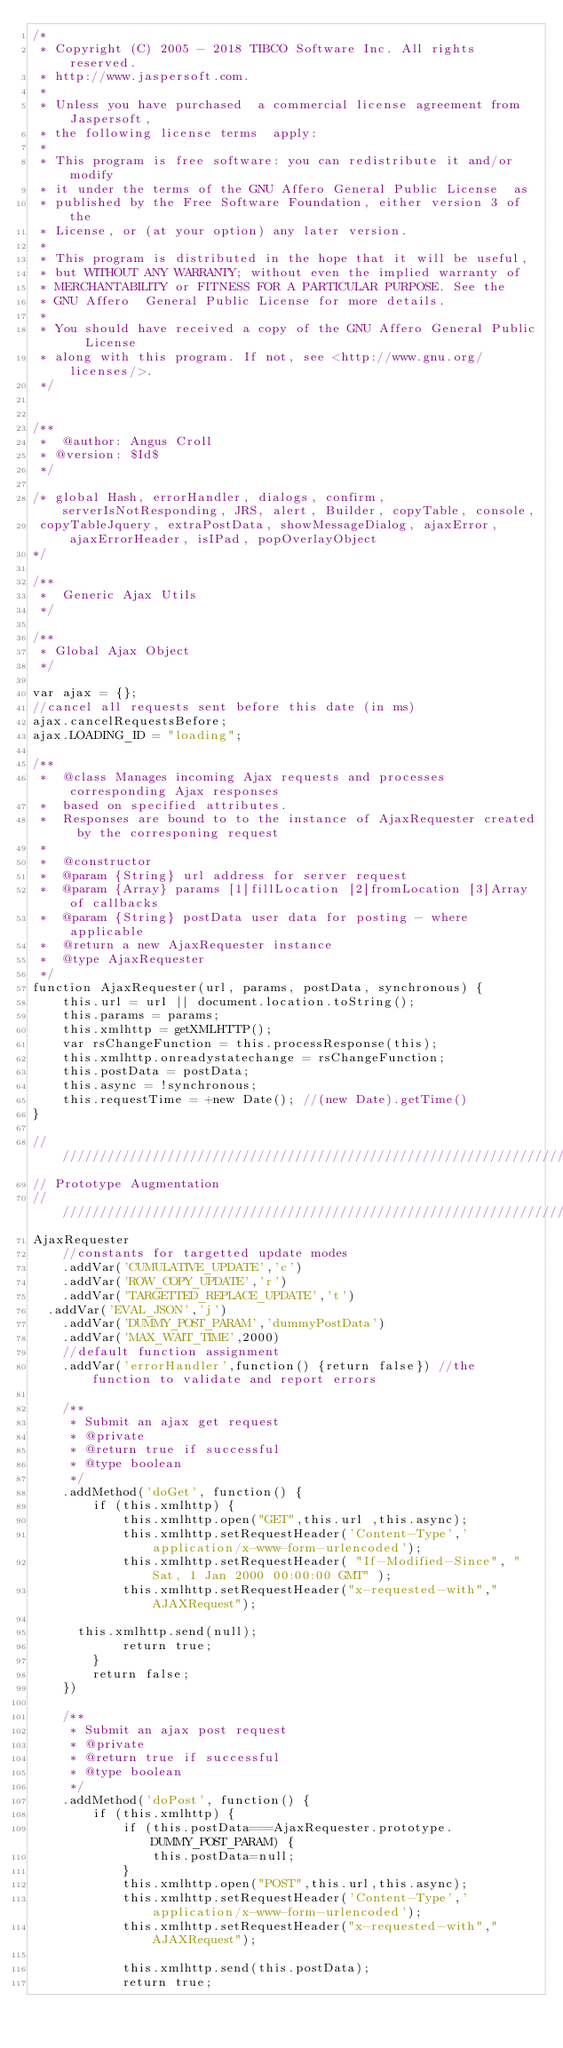Convert code to text. <code><loc_0><loc_0><loc_500><loc_500><_JavaScript_>/*
 * Copyright (C) 2005 - 2018 TIBCO Software Inc. All rights reserved.
 * http://www.jaspersoft.com.
 *
 * Unless you have purchased  a commercial license agreement from Jaspersoft,
 * the following license terms  apply:
 *
 * This program is free software: you can redistribute it and/or  modify
 * it under the terms of the GNU Affero General Public License  as
 * published by the Free Software Foundation, either version 3 of  the
 * License, or (at your option) any later version.
 *
 * This program is distributed in the hope that it will be useful,
 * but WITHOUT ANY WARRANTY; without even the implied warranty of
 * MERCHANTABILITY or FITNESS FOR A PARTICULAR PURPOSE. See the
 * GNU Affero  General Public License for more details.
 *
 * You should have received a copy of the GNU Affero General Public  License
 * along with this program. If not, see <http://www.gnu.org/licenses/>.
 */


/**
 *  @author: Angus Croll
 * @version: $Id$
 */

/* global Hash, errorHandler, dialogs, confirm, serverIsNotResponding, JRS, alert, Builder, copyTable, console,
 copyTableJquery, extraPostData, showMessageDialog, ajaxError, ajaxErrorHeader, isIPad, popOverlayObject
*/

/**
 *  Generic Ajax Utils
 */

/**
 * Global Ajax Object
 */

var ajax = {};
//cancel all requests sent before this date (in ms)
ajax.cancelRequestsBefore;
ajax.LOADING_ID = "loading";

/**
 *  @class Manages incoming Ajax requests and processes corresponding Ajax responses
 *  based on specified attributes.
 *  Responses are bound to to the instance of AjaxRequester created by the corresponing request
 *
 *  @constructor
 *  @param {String} url address for server request
 *  @param {Array} params [1]fillLocation [2]fromLocation [3]Array of callbacks
 *  @param {String} postData user data for posting - where applicable
 *  @return a new AjaxRequester instance
 *  @type AjaxRequester
 */
function AjaxRequester(url, params, postData, synchronous) {
    this.url = url || document.location.toString();
    this.params = params;
    this.xmlhttp = getXMLHTTP();
    var rsChangeFunction = this.processResponse(this);
    this.xmlhttp.onreadystatechange = rsChangeFunction;
    this.postData = postData;
    this.async = !synchronous;
    this.requestTime = +new Date(); //(new Date).getTime()
}

/////////////////////////////////////////////////////////////////////////
// Prototype Augmentation
/////////////////////////////////////////////////////////////////////////
AjaxRequester
    //constants for targetted update modes
    .addVar('CUMULATIVE_UPDATE','c')
    .addVar('ROW_COPY_UPDATE','r')
    .addVar('TARGETTED_REPLACE_UPDATE','t')
	.addVar('EVAL_JSON','j')
    .addVar('DUMMY_POST_PARAM','dummyPostData')
    .addVar('MAX_WAIT_TIME',2000)
    //default function assignment
    .addVar('errorHandler',function() {return false}) //the function to validate and report errors

    /**
     * Submit an ajax get request
     * @private
     * @return true if successful
     * @type boolean
     */
    .addMethod('doGet', function() {
        if (this.xmlhttp) {
            this.xmlhttp.open("GET",this.url ,this.async);
            this.xmlhttp.setRequestHeader('Content-Type','application/x-www-form-urlencoded');
            this.xmlhttp.setRequestHeader( "If-Modified-Since", "Sat, 1 Jan 2000 00:00:00 GMT" );
            this.xmlhttp.setRequestHeader("x-requested-with","AJAXRequest");

			this.xmlhttp.send(null);
            return true;
        }
        return false;
    })

    /**
     * Submit an ajax post request
     * @private
     * @return true if successful
     * @type boolean
     */
    .addMethod('doPost', function() {
        if (this.xmlhttp) {
            if (this.postData===AjaxRequester.prototype.DUMMY_POST_PARAM) {
                this.postData=null;
            }
            this.xmlhttp.open("POST",this.url,this.async);
            this.xmlhttp.setRequestHeader('Content-Type','application/x-www-form-urlencoded');
            this.xmlhttp.setRequestHeader("x-requested-with","AJAXRequest");

            this.xmlhttp.send(this.postData);
            return true;</code> 